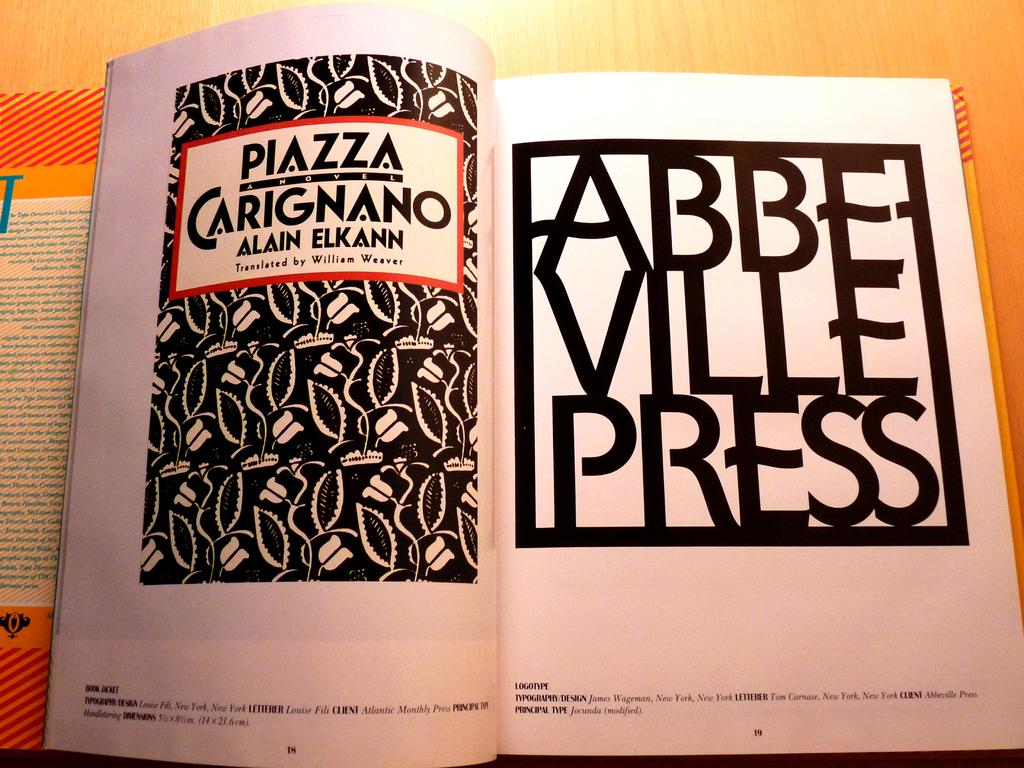Provide a one-sentence caption for the provided image. A book open to the title page showing what press made it. 